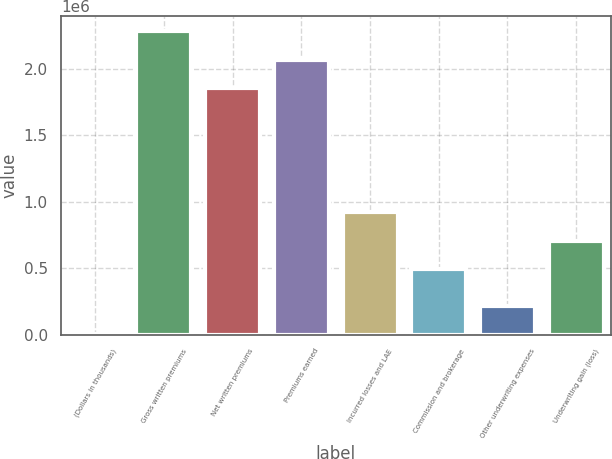Convert chart to OTSL. <chart><loc_0><loc_0><loc_500><loc_500><bar_chart><fcel>(Dollars in thousands)<fcel>Gross written premiums<fcel>Net written premiums<fcel>Premiums earned<fcel>Incurred losses and LAE<fcel>Commission and brokerage<fcel>Other underwriting expenses<fcel>Underwriting gain (loss)<nl><fcel>2015<fcel>2.28503e+06<fcel>1.85585e+06<fcel>2.07044e+06<fcel>922436<fcel>493261<fcel>216603<fcel>707849<nl></chart> 